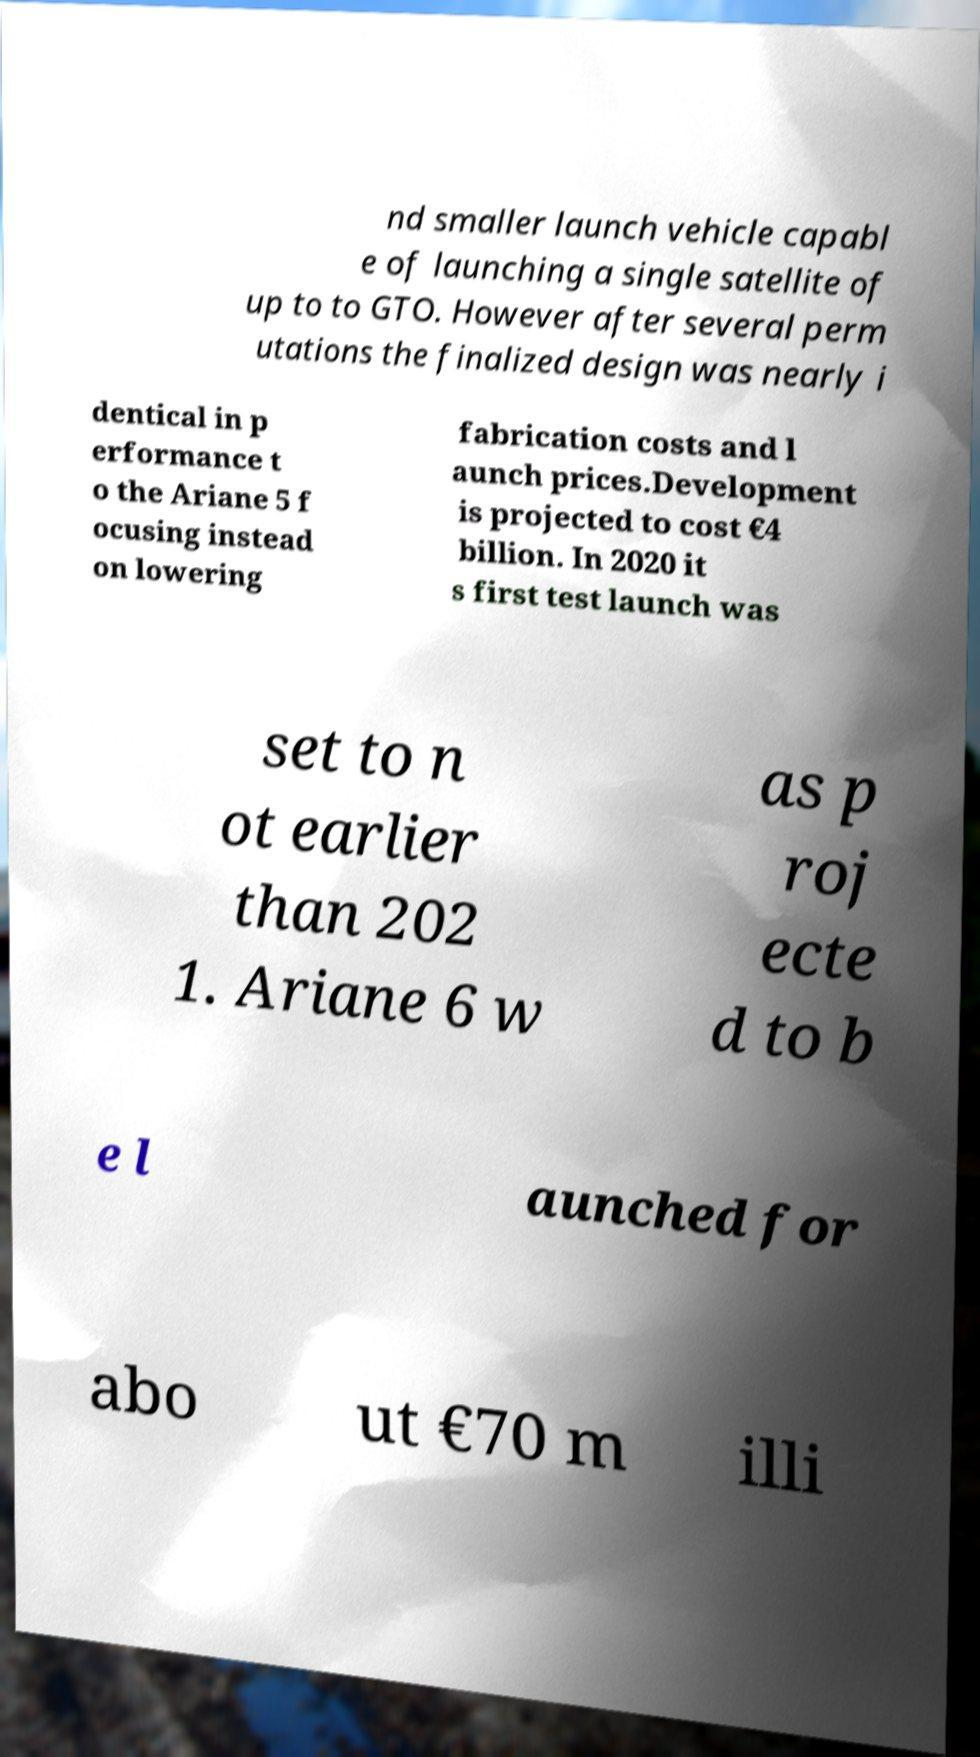Can you accurately transcribe the text from the provided image for me? nd smaller launch vehicle capabl e of launching a single satellite of up to to GTO. However after several perm utations the finalized design was nearly i dentical in p erformance t o the Ariane 5 f ocusing instead on lowering fabrication costs and l aunch prices.Development is projected to cost €4 billion. In 2020 it s first test launch was set to n ot earlier than 202 1. Ariane 6 w as p roj ecte d to b e l aunched for abo ut €70 m illi 